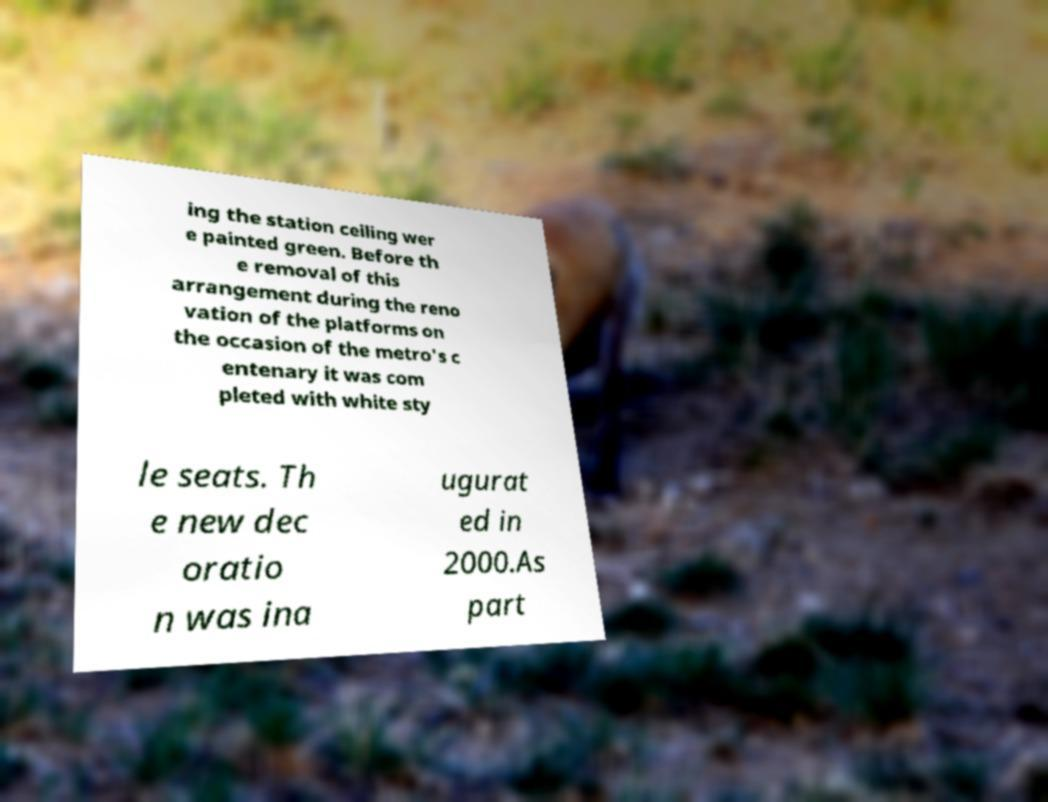Can you accurately transcribe the text from the provided image for me? ing the station ceiling wer e painted green. Before th e removal of this arrangement during the reno vation of the platforms on the occasion of the metro's c entenary it was com pleted with white sty le seats. Th e new dec oratio n was ina ugurat ed in 2000.As part 